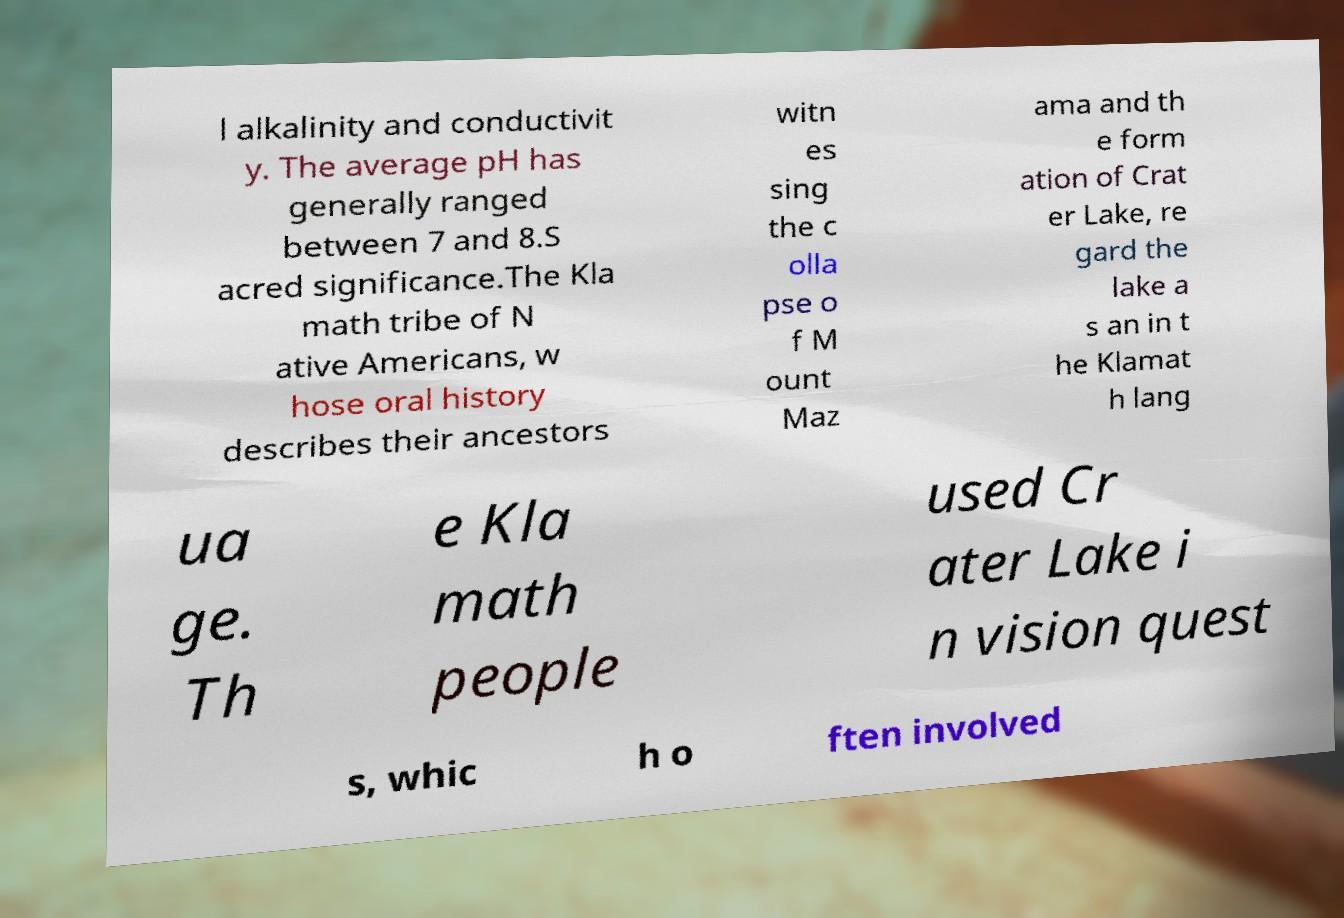Could you extract and type out the text from this image? l alkalinity and conductivit y. The average pH has generally ranged between 7 and 8.S acred significance.The Kla math tribe of N ative Americans, w hose oral history describes their ancestors witn es sing the c olla pse o f M ount Maz ama and th e form ation of Crat er Lake, re gard the lake a s an in t he Klamat h lang ua ge. Th e Kla math people used Cr ater Lake i n vision quest s, whic h o ften involved 